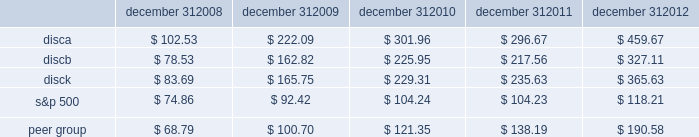Stock performance graph the following graph sets forth the cumulative total shareholder return on our series a common stock , series b common stock and series c common stock as compared with the cumulative total return of the companies listed in the standard and poor 2019s 500 stock index ( 201cs&p 500 index 201d ) and a peer group of companies comprised of cbs corporation class b common stock , news corporation class a common stock , scripps network interactive , inc. , time warner , inc. , viacom , inc .
Class b common stock and the walt disney company .
The graph assumes $ 100 originally invested on september 18 , 2008 , the date upon which our common stock began trading , in each of our series a common stock , series b common stock and series c common stock , the s&p 500 index , and the stock of our peer group companies , including reinvestment of dividends , for the period september 18 , 2008 through december 31 , 2008 and the years ended december 31 , 2009 , 2010 , 2011 , and 2012 .
December 31 , december 31 , december 31 , december 31 , december 31 .
Equity compensation plan information information regarding securities authorized for issuance under equity compensation plans will be set forth in our definitive proxy statement for our 2013 annual meeting of stockholders under the caption 201csecurities authorized for issuance under equity compensation plans , 201d which is incorporated herein by reference. .
By what percent did the c series outperform the s&p 500 over 5 years? 
Computations: ((365.63 - 118.21) / 118.21)
Answer: 2.09305. 